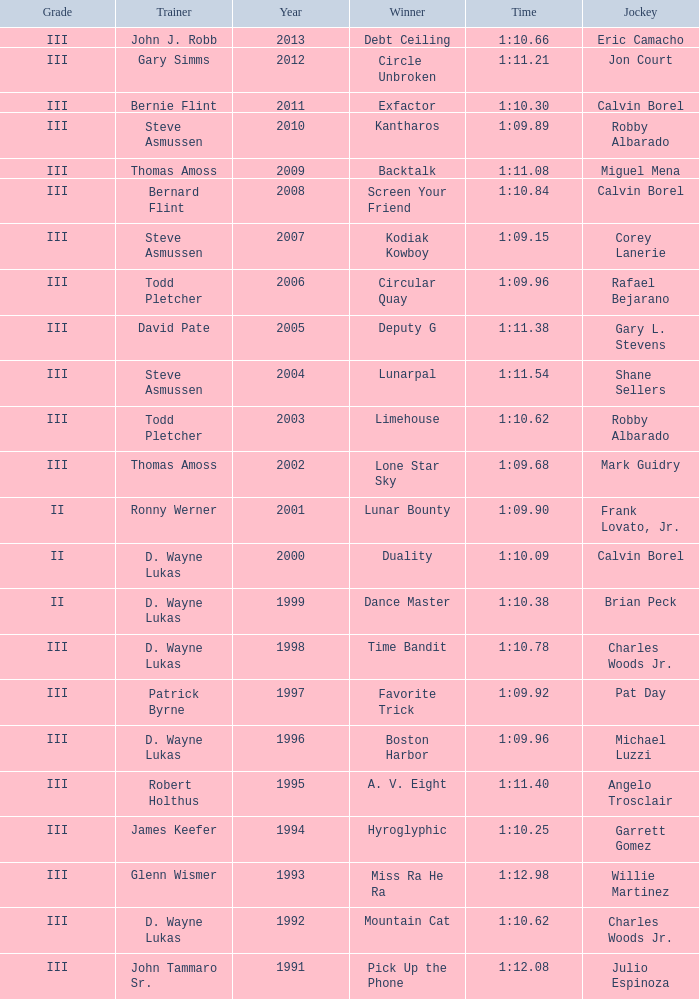Which trainer won the hyroglyphic in a year that was before 2010? James Keefer. 